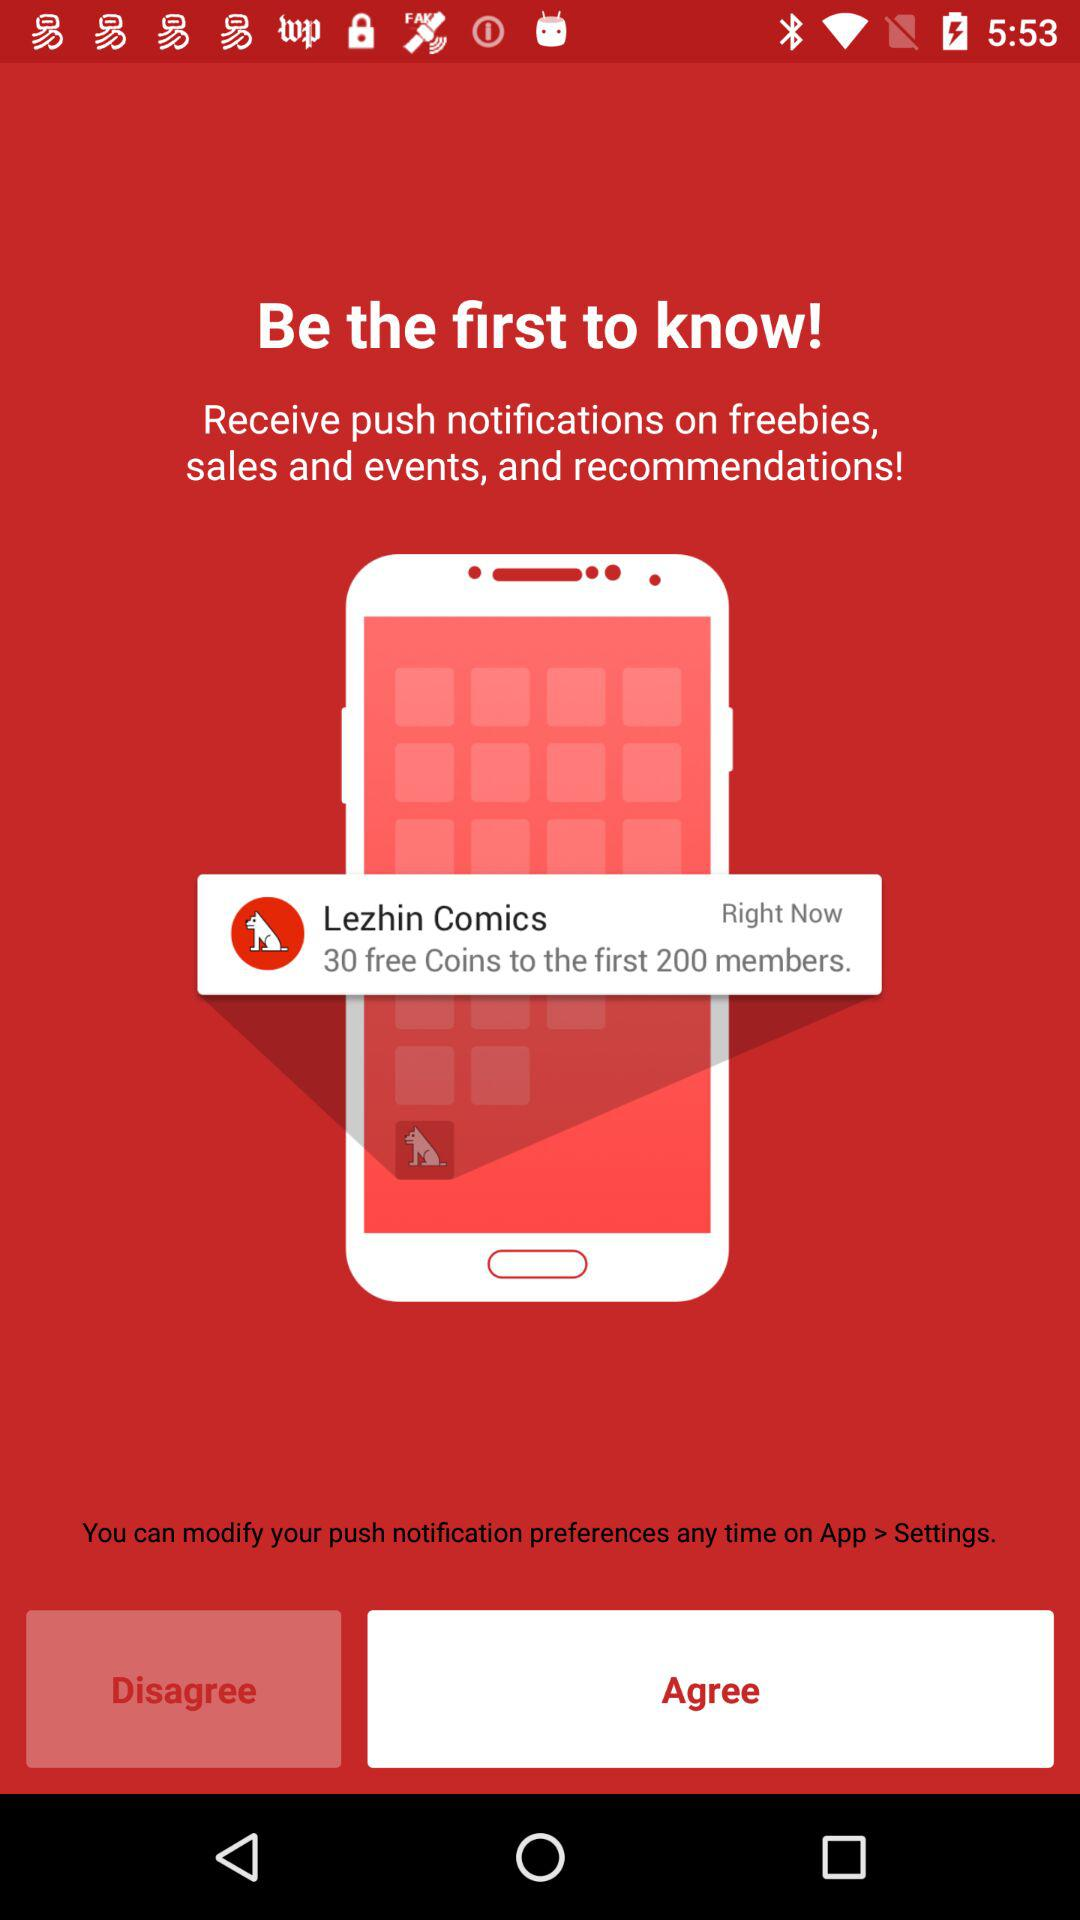How many free coins are there for the first 200 members? There are 30 free coins for the first 200 members. 